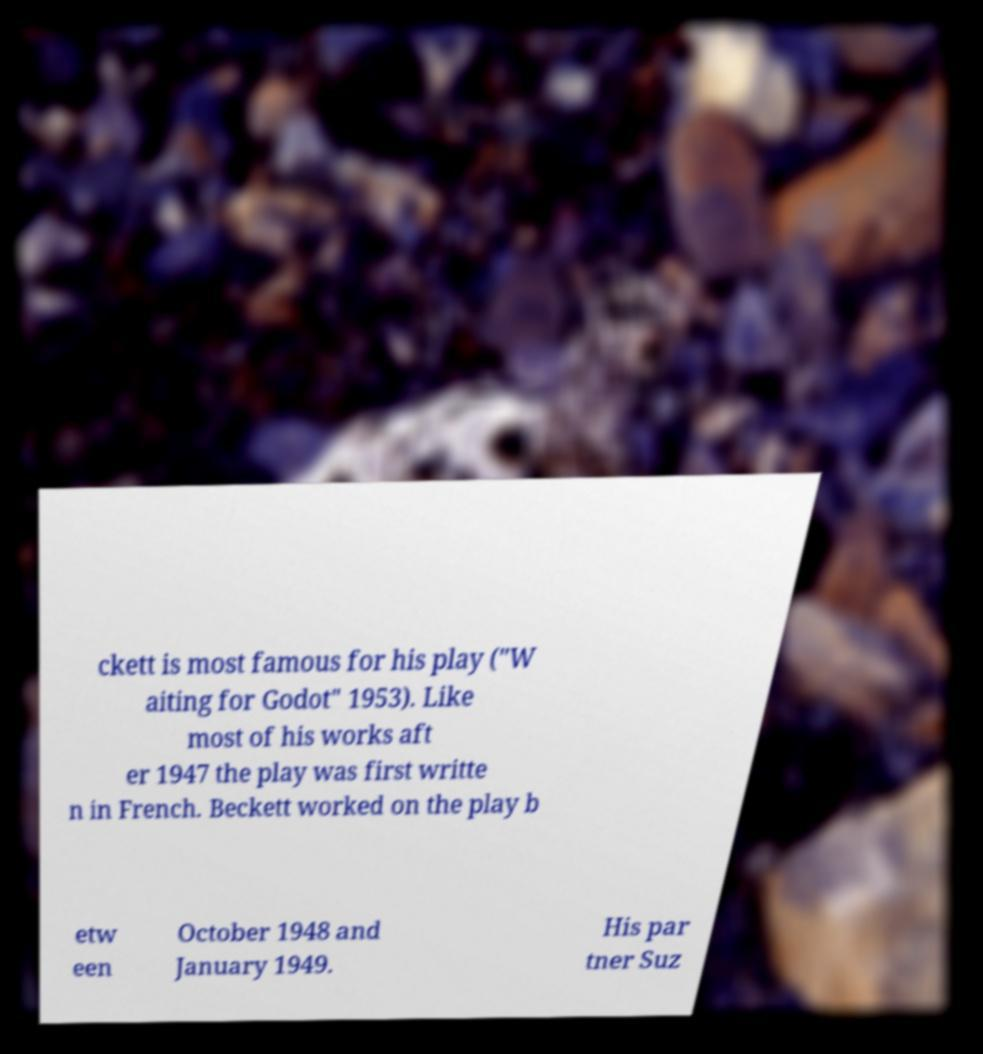Please identify and transcribe the text found in this image. ckett is most famous for his play ("W aiting for Godot" 1953). Like most of his works aft er 1947 the play was first writte n in French. Beckett worked on the play b etw een October 1948 and January 1949. His par tner Suz 